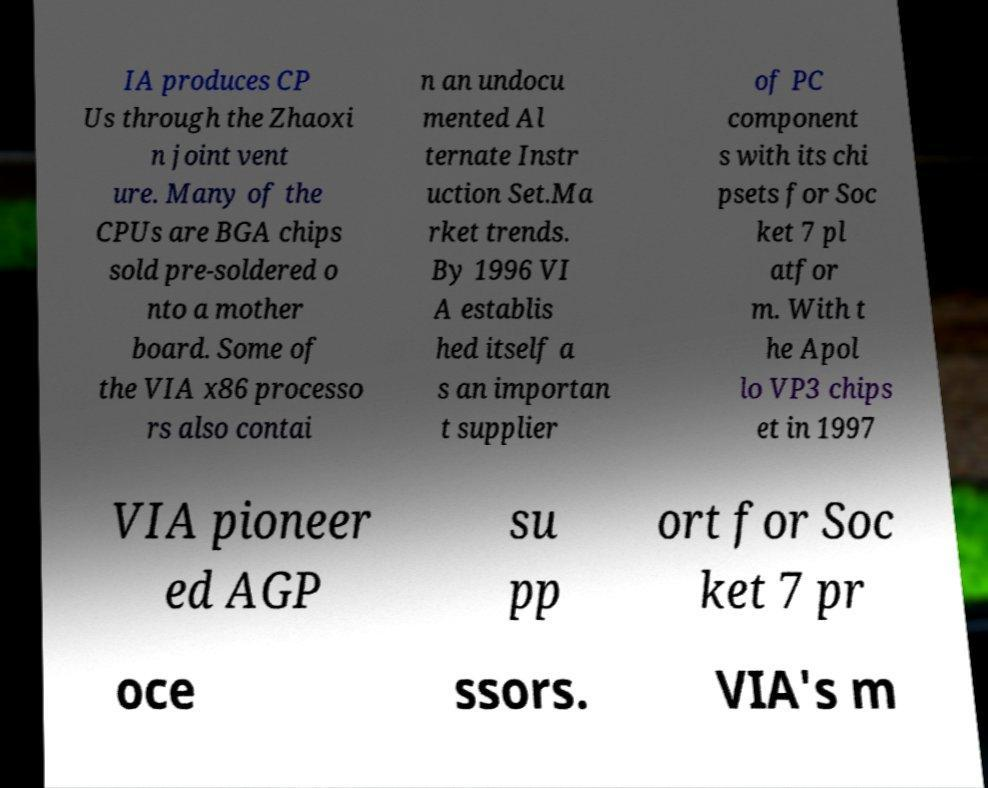Could you extract and type out the text from this image? IA produces CP Us through the Zhaoxi n joint vent ure. Many of the CPUs are BGA chips sold pre-soldered o nto a mother board. Some of the VIA x86 processo rs also contai n an undocu mented Al ternate Instr uction Set.Ma rket trends. By 1996 VI A establis hed itself a s an importan t supplier of PC component s with its chi psets for Soc ket 7 pl atfor m. With t he Apol lo VP3 chips et in 1997 VIA pioneer ed AGP su pp ort for Soc ket 7 pr oce ssors. VIA's m 